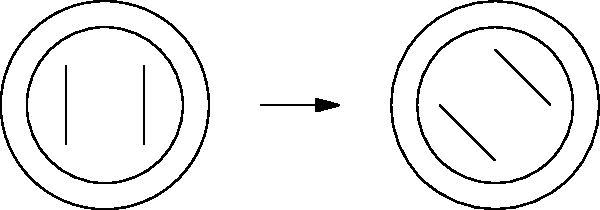As a medical professional developing a healthcare app, you need to implement a feature for comparing brain MRI scans. The image shows two brain MRI scans, with the right scan rotated 45 degrees clockwise. How many degrees and in which direction should the right scan be rotated to align it with the left scan for accurate comparison? To align the rotated brain MRI scan with the original scan, we need to follow these steps:

1. Identify the current rotation: The right scan is rotated 45 degrees clockwise from the original position.

2. Determine the required rotation: To align the scans, we need to rotate the right scan in the opposite direction (counterclockwise) by the same angle.

3. Calculate the rotation angle: Since the scan was rotated 45 degrees clockwise, we need to rotate it 45 degrees counterclockwise to return it to its original orientation.

4. Verify the direction: Counterclockwise rotation is the correct direction to undo a clockwise rotation.

Therefore, to align the right scan with the left scan, it should be rotated 45 degrees counterclockwise.
Answer: 45 degrees counterclockwise 